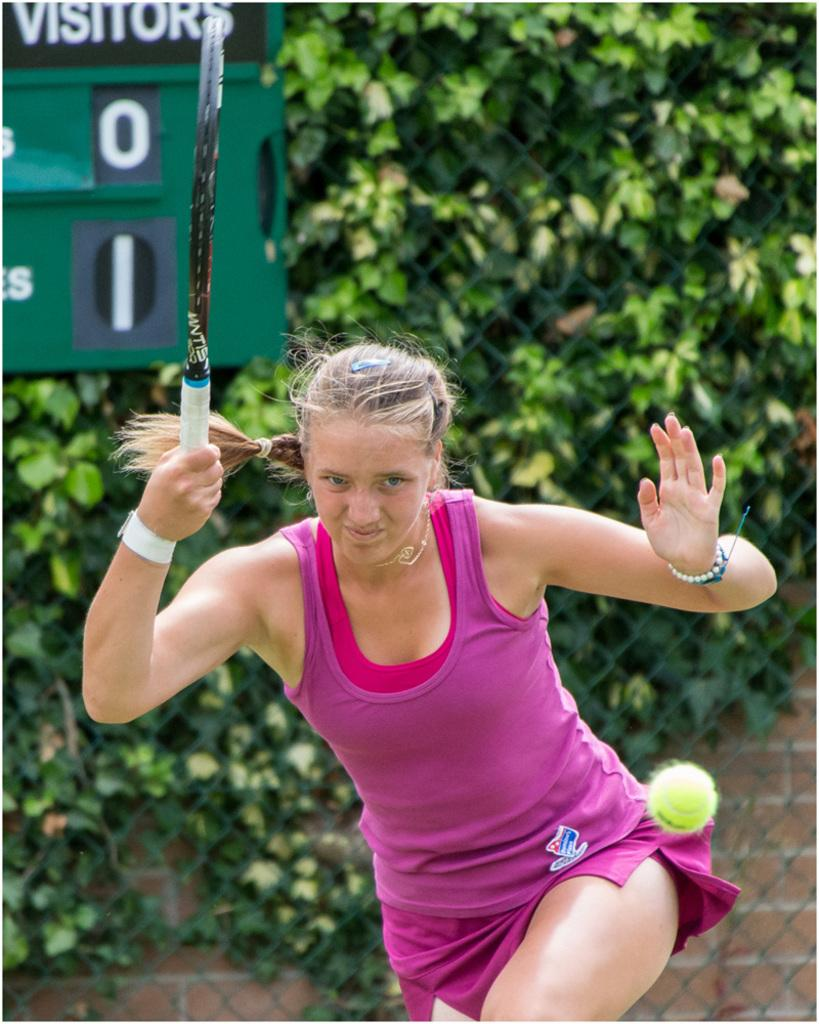What type of vegetation can be seen in the image? There are trees in the image. Who is present in the image? There is a woman in the image. What object is the woman holding? The woman is holding a shuttle bat. How many snails can be seen climbing on the trees in the image? There are no snails visible in the image; it only features trees and a woman holding a shuttle bat. What type of jelly is being used to hold the shuttle bat in the image? There is no jelly present in the image; the woman is simply holding the shuttle bat. 